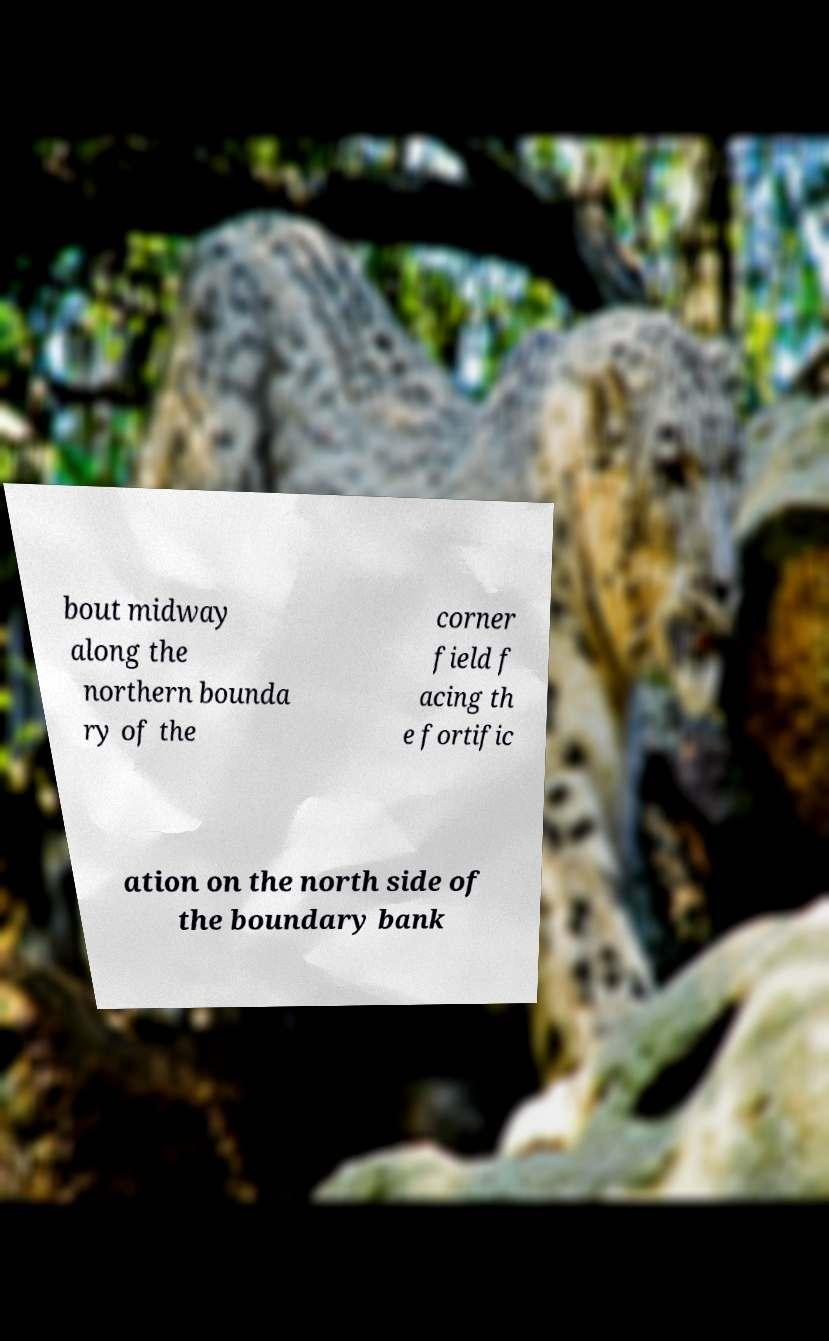For documentation purposes, I need the text within this image transcribed. Could you provide that? bout midway along the northern bounda ry of the corner field f acing th e fortific ation on the north side of the boundary bank 